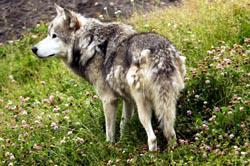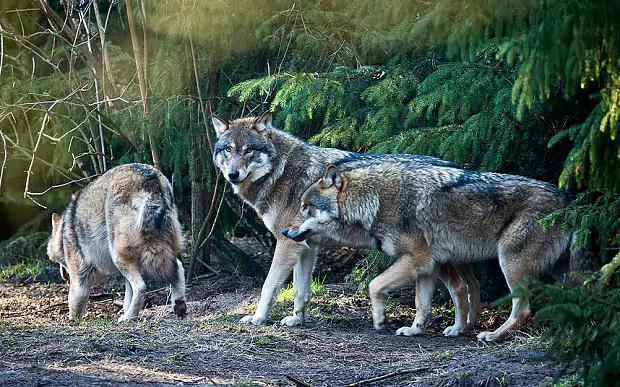The first image is the image on the left, the second image is the image on the right. For the images shown, is this caption "There are more animals standing in the image on the left." true? Answer yes or no. No. The first image is the image on the left, the second image is the image on the right. Examine the images to the left and right. Is the description "The left image contains no more than two wolves." accurate? Answer yes or no. Yes. 